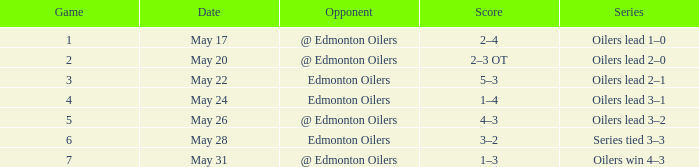Series of oilers win 4–3 had what highest game? 7.0. 